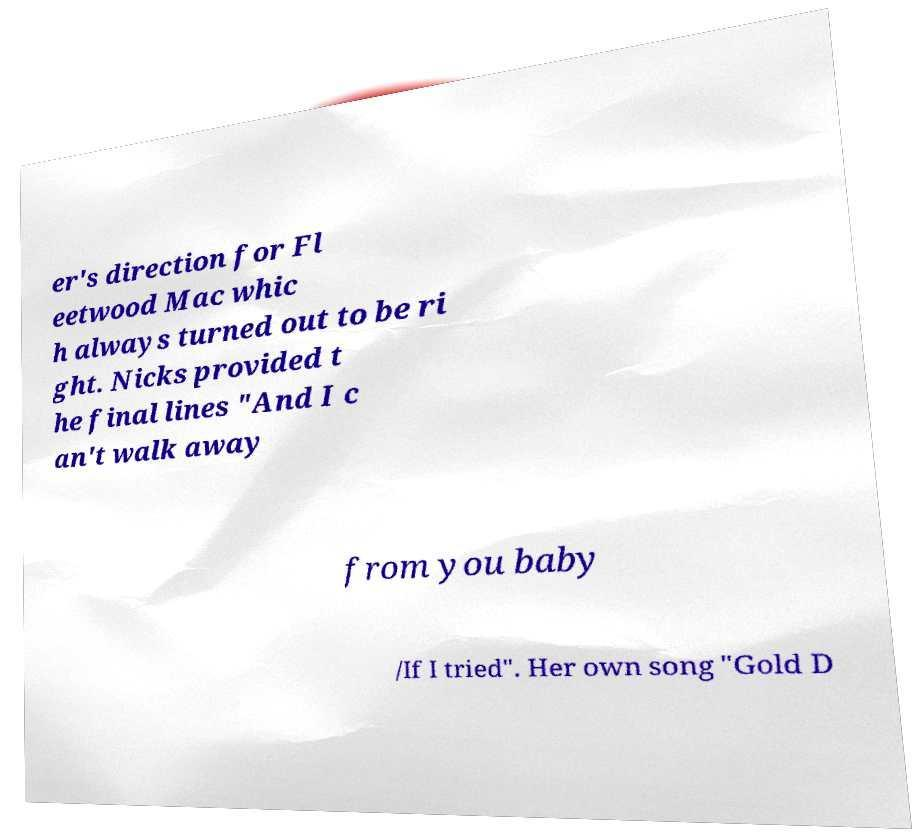What messages or text are displayed in this image? I need them in a readable, typed format. er's direction for Fl eetwood Mac whic h always turned out to be ri ght. Nicks provided t he final lines "And I c an't walk away from you baby /If I tried". Her own song "Gold D 